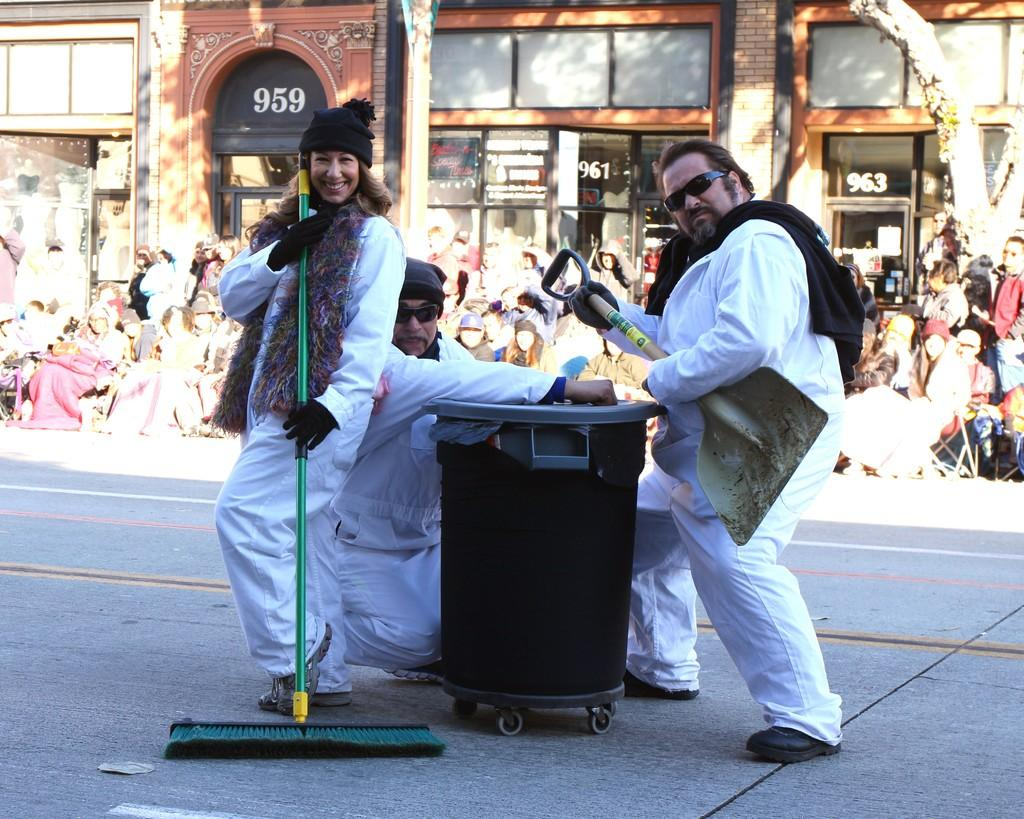<image>
Write a terse but informative summary of the picture. A street cleaning team poses in the middle of the street between the address numbers 959 and 963. 